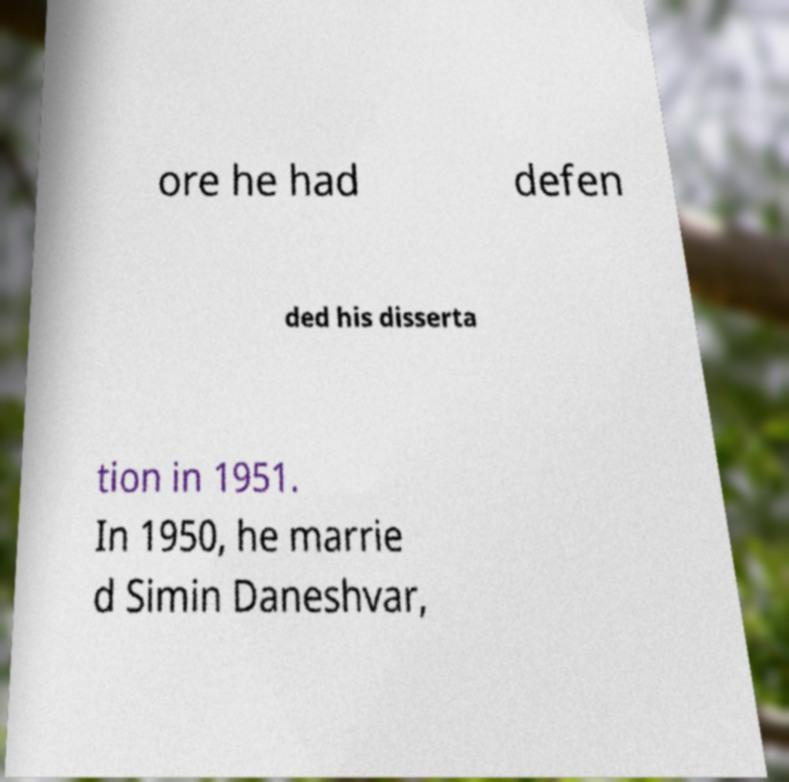Please read and relay the text visible in this image. What does it say? ore he had defen ded his disserta tion in 1951. In 1950, he marrie d Simin Daneshvar, 